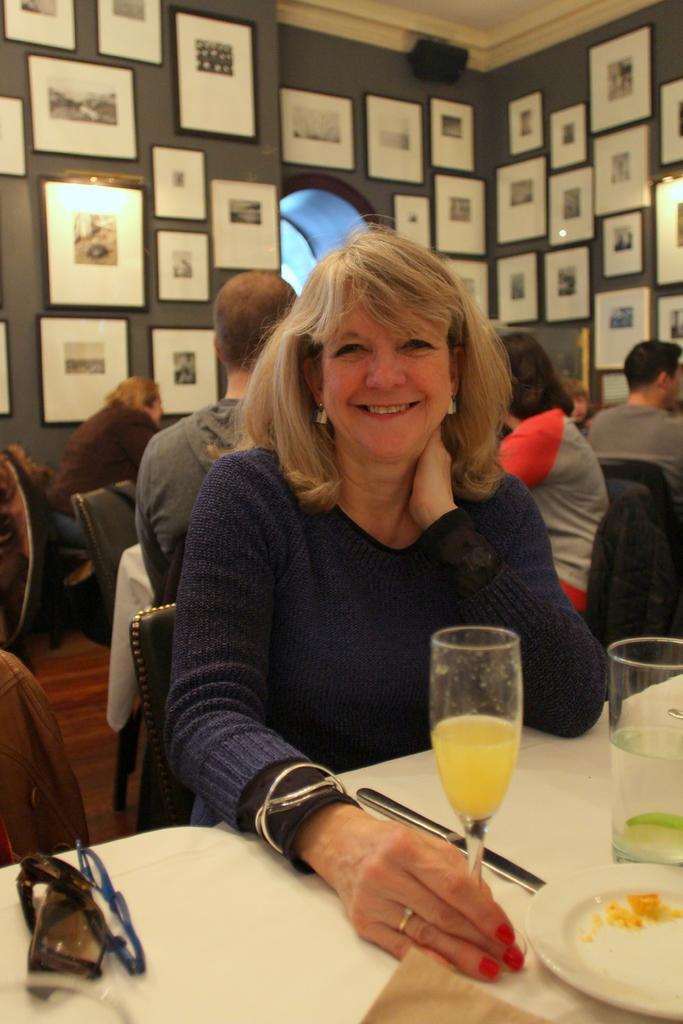Please provide a concise description of this image. A wearing bangles is holding a glass and smiling and sitting on a chair. In front of her there is a table. On the table there are goggles, plates, glasses, and a knife. In the background there are many persons sitting on chairs. On the wall there are many photo frames. 